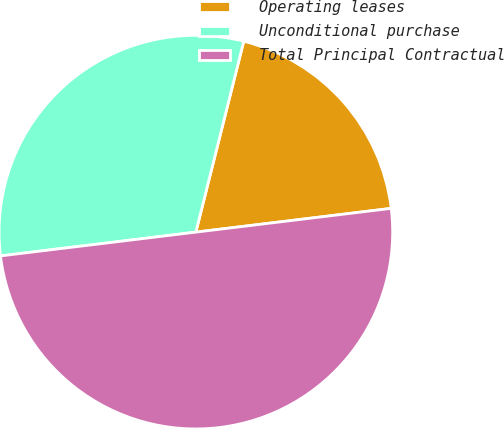Convert chart to OTSL. <chart><loc_0><loc_0><loc_500><loc_500><pie_chart><fcel>Operating leases<fcel>Unconditional purchase<fcel>Total Principal Contractual<nl><fcel>19.16%<fcel>30.84%<fcel>50.0%<nl></chart> 